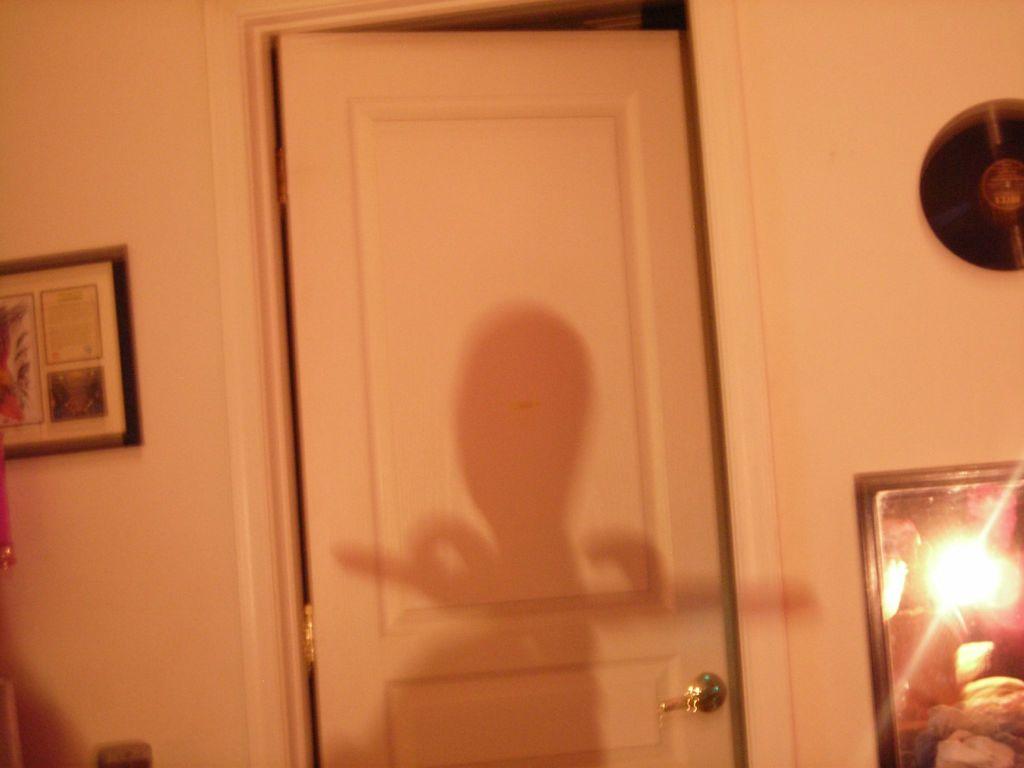Describe this image in one or two sentences. As we can see in the image there is a wall, photo frame, door and a mirror. 